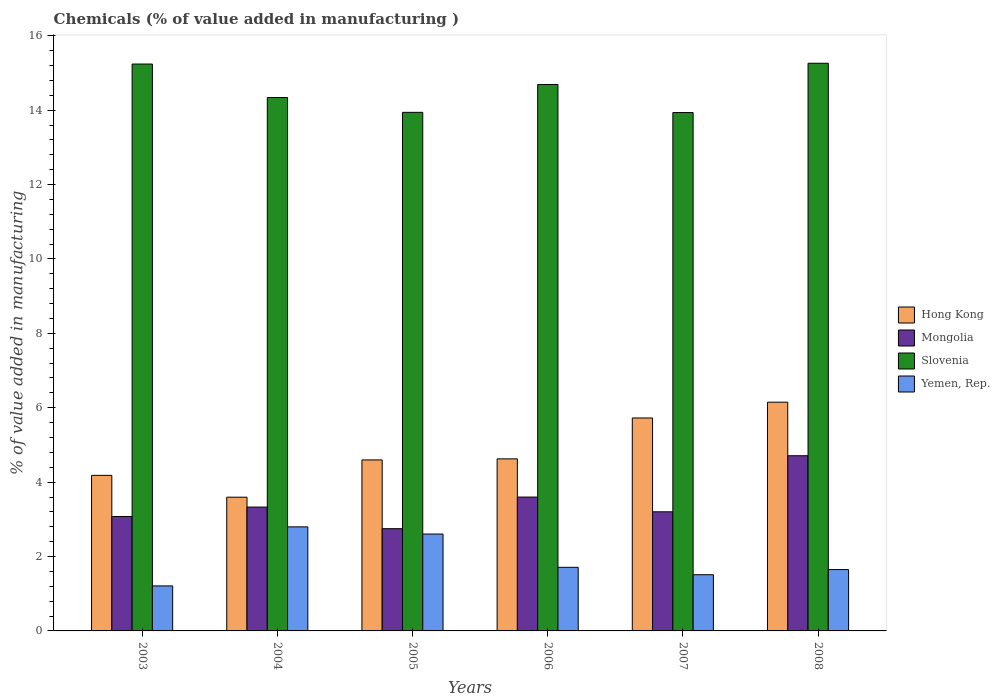Are the number of bars per tick equal to the number of legend labels?
Ensure brevity in your answer.  Yes. How many bars are there on the 6th tick from the left?
Make the answer very short. 4. What is the label of the 4th group of bars from the left?
Provide a succinct answer. 2006. What is the value added in manufacturing chemicals in Mongolia in 2007?
Make the answer very short. 3.2. Across all years, what is the maximum value added in manufacturing chemicals in Hong Kong?
Offer a terse response. 6.15. Across all years, what is the minimum value added in manufacturing chemicals in Hong Kong?
Keep it short and to the point. 3.59. In which year was the value added in manufacturing chemicals in Hong Kong maximum?
Your response must be concise. 2008. In which year was the value added in manufacturing chemicals in Hong Kong minimum?
Ensure brevity in your answer.  2004. What is the total value added in manufacturing chemicals in Hong Kong in the graph?
Give a very brief answer. 28.87. What is the difference between the value added in manufacturing chemicals in Mongolia in 2003 and that in 2005?
Offer a very short reply. 0.33. What is the difference between the value added in manufacturing chemicals in Hong Kong in 2007 and the value added in manufacturing chemicals in Mongolia in 2003?
Give a very brief answer. 2.65. What is the average value added in manufacturing chemicals in Yemen, Rep. per year?
Your answer should be compact. 1.91. In the year 2008, what is the difference between the value added in manufacturing chemicals in Slovenia and value added in manufacturing chemicals in Mongolia?
Your answer should be compact. 10.55. In how many years, is the value added in manufacturing chemicals in Yemen, Rep. greater than 15.2 %?
Offer a terse response. 0. What is the ratio of the value added in manufacturing chemicals in Slovenia in 2004 to that in 2008?
Make the answer very short. 0.94. Is the difference between the value added in manufacturing chemicals in Slovenia in 2003 and 2008 greater than the difference between the value added in manufacturing chemicals in Mongolia in 2003 and 2008?
Offer a very short reply. Yes. What is the difference between the highest and the second highest value added in manufacturing chemicals in Yemen, Rep.?
Your answer should be very brief. 0.19. What is the difference between the highest and the lowest value added in manufacturing chemicals in Mongolia?
Provide a short and direct response. 1.96. In how many years, is the value added in manufacturing chemicals in Slovenia greater than the average value added in manufacturing chemicals in Slovenia taken over all years?
Give a very brief answer. 3. Is it the case that in every year, the sum of the value added in manufacturing chemicals in Hong Kong and value added in manufacturing chemicals in Slovenia is greater than the sum of value added in manufacturing chemicals in Mongolia and value added in manufacturing chemicals in Yemen, Rep.?
Your answer should be compact. Yes. What does the 1st bar from the left in 2004 represents?
Give a very brief answer. Hong Kong. What does the 1st bar from the right in 2003 represents?
Provide a succinct answer. Yemen, Rep. Is it the case that in every year, the sum of the value added in manufacturing chemicals in Mongolia and value added in manufacturing chemicals in Hong Kong is greater than the value added in manufacturing chemicals in Yemen, Rep.?
Offer a very short reply. Yes. How many bars are there?
Make the answer very short. 24. How many years are there in the graph?
Offer a very short reply. 6. What is the title of the graph?
Ensure brevity in your answer.  Chemicals (% of value added in manufacturing ). Does "Sub-Saharan Africa (all income levels)" appear as one of the legend labels in the graph?
Keep it short and to the point. No. What is the label or title of the Y-axis?
Your answer should be compact. % of value added in manufacturing. What is the % of value added in manufacturing of Hong Kong in 2003?
Provide a succinct answer. 4.18. What is the % of value added in manufacturing of Mongolia in 2003?
Provide a short and direct response. 3.08. What is the % of value added in manufacturing in Slovenia in 2003?
Offer a terse response. 15.24. What is the % of value added in manufacturing of Yemen, Rep. in 2003?
Keep it short and to the point. 1.21. What is the % of value added in manufacturing in Hong Kong in 2004?
Give a very brief answer. 3.59. What is the % of value added in manufacturing of Mongolia in 2004?
Keep it short and to the point. 3.33. What is the % of value added in manufacturing in Slovenia in 2004?
Provide a short and direct response. 14.34. What is the % of value added in manufacturing in Yemen, Rep. in 2004?
Your answer should be compact. 2.8. What is the % of value added in manufacturing in Hong Kong in 2005?
Offer a very short reply. 4.6. What is the % of value added in manufacturing of Mongolia in 2005?
Provide a short and direct response. 2.75. What is the % of value added in manufacturing in Slovenia in 2005?
Keep it short and to the point. 13.94. What is the % of value added in manufacturing in Yemen, Rep. in 2005?
Your answer should be compact. 2.6. What is the % of value added in manufacturing in Hong Kong in 2006?
Your answer should be compact. 4.63. What is the % of value added in manufacturing in Mongolia in 2006?
Your answer should be compact. 3.6. What is the % of value added in manufacturing of Slovenia in 2006?
Keep it short and to the point. 14.69. What is the % of value added in manufacturing of Yemen, Rep. in 2006?
Keep it short and to the point. 1.71. What is the % of value added in manufacturing in Hong Kong in 2007?
Your answer should be compact. 5.72. What is the % of value added in manufacturing of Mongolia in 2007?
Ensure brevity in your answer.  3.2. What is the % of value added in manufacturing in Slovenia in 2007?
Ensure brevity in your answer.  13.93. What is the % of value added in manufacturing of Yemen, Rep. in 2007?
Your response must be concise. 1.51. What is the % of value added in manufacturing in Hong Kong in 2008?
Your answer should be compact. 6.15. What is the % of value added in manufacturing in Mongolia in 2008?
Offer a very short reply. 4.71. What is the % of value added in manufacturing in Slovenia in 2008?
Give a very brief answer. 15.26. What is the % of value added in manufacturing in Yemen, Rep. in 2008?
Ensure brevity in your answer.  1.65. Across all years, what is the maximum % of value added in manufacturing of Hong Kong?
Make the answer very short. 6.15. Across all years, what is the maximum % of value added in manufacturing in Mongolia?
Give a very brief answer. 4.71. Across all years, what is the maximum % of value added in manufacturing of Slovenia?
Offer a very short reply. 15.26. Across all years, what is the maximum % of value added in manufacturing in Yemen, Rep.?
Make the answer very short. 2.8. Across all years, what is the minimum % of value added in manufacturing of Hong Kong?
Provide a succinct answer. 3.59. Across all years, what is the minimum % of value added in manufacturing in Mongolia?
Your response must be concise. 2.75. Across all years, what is the minimum % of value added in manufacturing of Slovenia?
Your answer should be compact. 13.93. Across all years, what is the minimum % of value added in manufacturing of Yemen, Rep.?
Make the answer very short. 1.21. What is the total % of value added in manufacturing of Hong Kong in the graph?
Provide a short and direct response. 28.87. What is the total % of value added in manufacturing of Mongolia in the graph?
Keep it short and to the point. 20.66. What is the total % of value added in manufacturing of Slovenia in the graph?
Ensure brevity in your answer.  87.41. What is the total % of value added in manufacturing of Yemen, Rep. in the graph?
Keep it short and to the point. 11.48. What is the difference between the % of value added in manufacturing of Hong Kong in 2003 and that in 2004?
Make the answer very short. 0.59. What is the difference between the % of value added in manufacturing of Mongolia in 2003 and that in 2004?
Make the answer very short. -0.25. What is the difference between the % of value added in manufacturing of Slovenia in 2003 and that in 2004?
Make the answer very short. 0.9. What is the difference between the % of value added in manufacturing of Yemen, Rep. in 2003 and that in 2004?
Offer a terse response. -1.59. What is the difference between the % of value added in manufacturing of Hong Kong in 2003 and that in 2005?
Keep it short and to the point. -0.41. What is the difference between the % of value added in manufacturing of Mongolia in 2003 and that in 2005?
Make the answer very short. 0.33. What is the difference between the % of value added in manufacturing of Slovenia in 2003 and that in 2005?
Give a very brief answer. 1.3. What is the difference between the % of value added in manufacturing in Yemen, Rep. in 2003 and that in 2005?
Keep it short and to the point. -1.39. What is the difference between the % of value added in manufacturing of Hong Kong in 2003 and that in 2006?
Your answer should be compact. -0.44. What is the difference between the % of value added in manufacturing in Mongolia in 2003 and that in 2006?
Your response must be concise. -0.52. What is the difference between the % of value added in manufacturing in Slovenia in 2003 and that in 2006?
Your answer should be compact. 0.55. What is the difference between the % of value added in manufacturing in Yemen, Rep. in 2003 and that in 2006?
Provide a short and direct response. -0.5. What is the difference between the % of value added in manufacturing of Hong Kong in 2003 and that in 2007?
Give a very brief answer. -1.54. What is the difference between the % of value added in manufacturing of Mongolia in 2003 and that in 2007?
Your answer should be compact. -0.13. What is the difference between the % of value added in manufacturing of Slovenia in 2003 and that in 2007?
Provide a short and direct response. 1.3. What is the difference between the % of value added in manufacturing in Yemen, Rep. in 2003 and that in 2007?
Provide a short and direct response. -0.3. What is the difference between the % of value added in manufacturing of Hong Kong in 2003 and that in 2008?
Offer a terse response. -1.97. What is the difference between the % of value added in manufacturing of Mongolia in 2003 and that in 2008?
Give a very brief answer. -1.63. What is the difference between the % of value added in manufacturing of Slovenia in 2003 and that in 2008?
Offer a very short reply. -0.02. What is the difference between the % of value added in manufacturing of Yemen, Rep. in 2003 and that in 2008?
Your answer should be very brief. -0.44. What is the difference between the % of value added in manufacturing of Hong Kong in 2004 and that in 2005?
Give a very brief answer. -1. What is the difference between the % of value added in manufacturing in Mongolia in 2004 and that in 2005?
Offer a very short reply. 0.58. What is the difference between the % of value added in manufacturing of Slovenia in 2004 and that in 2005?
Keep it short and to the point. 0.4. What is the difference between the % of value added in manufacturing of Yemen, Rep. in 2004 and that in 2005?
Your answer should be compact. 0.19. What is the difference between the % of value added in manufacturing of Hong Kong in 2004 and that in 2006?
Ensure brevity in your answer.  -1.03. What is the difference between the % of value added in manufacturing of Mongolia in 2004 and that in 2006?
Make the answer very short. -0.27. What is the difference between the % of value added in manufacturing of Slovenia in 2004 and that in 2006?
Keep it short and to the point. -0.35. What is the difference between the % of value added in manufacturing in Yemen, Rep. in 2004 and that in 2006?
Offer a terse response. 1.09. What is the difference between the % of value added in manufacturing of Hong Kong in 2004 and that in 2007?
Ensure brevity in your answer.  -2.13. What is the difference between the % of value added in manufacturing in Mongolia in 2004 and that in 2007?
Your answer should be compact. 0.13. What is the difference between the % of value added in manufacturing of Slovenia in 2004 and that in 2007?
Your response must be concise. 0.4. What is the difference between the % of value added in manufacturing in Yemen, Rep. in 2004 and that in 2007?
Offer a terse response. 1.29. What is the difference between the % of value added in manufacturing of Hong Kong in 2004 and that in 2008?
Your answer should be very brief. -2.55. What is the difference between the % of value added in manufacturing of Mongolia in 2004 and that in 2008?
Offer a terse response. -1.38. What is the difference between the % of value added in manufacturing in Slovenia in 2004 and that in 2008?
Your answer should be compact. -0.92. What is the difference between the % of value added in manufacturing of Yemen, Rep. in 2004 and that in 2008?
Your response must be concise. 1.15. What is the difference between the % of value added in manufacturing in Hong Kong in 2005 and that in 2006?
Your response must be concise. -0.03. What is the difference between the % of value added in manufacturing in Mongolia in 2005 and that in 2006?
Provide a succinct answer. -0.85. What is the difference between the % of value added in manufacturing in Slovenia in 2005 and that in 2006?
Your answer should be very brief. -0.75. What is the difference between the % of value added in manufacturing in Yemen, Rep. in 2005 and that in 2006?
Give a very brief answer. 0.89. What is the difference between the % of value added in manufacturing in Hong Kong in 2005 and that in 2007?
Provide a short and direct response. -1.13. What is the difference between the % of value added in manufacturing in Mongolia in 2005 and that in 2007?
Provide a succinct answer. -0.45. What is the difference between the % of value added in manufacturing in Slovenia in 2005 and that in 2007?
Offer a very short reply. 0.01. What is the difference between the % of value added in manufacturing of Yemen, Rep. in 2005 and that in 2007?
Keep it short and to the point. 1.09. What is the difference between the % of value added in manufacturing of Hong Kong in 2005 and that in 2008?
Your answer should be compact. -1.55. What is the difference between the % of value added in manufacturing in Mongolia in 2005 and that in 2008?
Provide a succinct answer. -1.96. What is the difference between the % of value added in manufacturing of Slovenia in 2005 and that in 2008?
Keep it short and to the point. -1.32. What is the difference between the % of value added in manufacturing of Yemen, Rep. in 2005 and that in 2008?
Your answer should be very brief. 0.96. What is the difference between the % of value added in manufacturing of Hong Kong in 2006 and that in 2007?
Your response must be concise. -1.1. What is the difference between the % of value added in manufacturing of Mongolia in 2006 and that in 2007?
Your answer should be compact. 0.4. What is the difference between the % of value added in manufacturing in Slovenia in 2006 and that in 2007?
Make the answer very short. 0.76. What is the difference between the % of value added in manufacturing of Yemen, Rep. in 2006 and that in 2007?
Keep it short and to the point. 0.2. What is the difference between the % of value added in manufacturing in Hong Kong in 2006 and that in 2008?
Your answer should be compact. -1.52. What is the difference between the % of value added in manufacturing of Mongolia in 2006 and that in 2008?
Ensure brevity in your answer.  -1.11. What is the difference between the % of value added in manufacturing of Slovenia in 2006 and that in 2008?
Your answer should be very brief. -0.57. What is the difference between the % of value added in manufacturing in Yemen, Rep. in 2006 and that in 2008?
Provide a short and direct response. 0.06. What is the difference between the % of value added in manufacturing in Hong Kong in 2007 and that in 2008?
Your response must be concise. -0.42. What is the difference between the % of value added in manufacturing in Mongolia in 2007 and that in 2008?
Give a very brief answer. -1.51. What is the difference between the % of value added in manufacturing in Slovenia in 2007 and that in 2008?
Offer a terse response. -1.33. What is the difference between the % of value added in manufacturing of Yemen, Rep. in 2007 and that in 2008?
Ensure brevity in your answer.  -0.14. What is the difference between the % of value added in manufacturing in Hong Kong in 2003 and the % of value added in manufacturing in Mongolia in 2004?
Your answer should be compact. 0.85. What is the difference between the % of value added in manufacturing of Hong Kong in 2003 and the % of value added in manufacturing of Slovenia in 2004?
Provide a succinct answer. -10.16. What is the difference between the % of value added in manufacturing in Hong Kong in 2003 and the % of value added in manufacturing in Yemen, Rep. in 2004?
Your answer should be very brief. 1.39. What is the difference between the % of value added in manufacturing of Mongolia in 2003 and the % of value added in manufacturing of Slovenia in 2004?
Keep it short and to the point. -11.26. What is the difference between the % of value added in manufacturing in Mongolia in 2003 and the % of value added in manufacturing in Yemen, Rep. in 2004?
Make the answer very short. 0.28. What is the difference between the % of value added in manufacturing in Slovenia in 2003 and the % of value added in manufacturing in Yemen, Rep. in 2004?
Give a very brief answer. 12.44. What is the difference between the % of value added in manufacturing in Hong Kong in 2003 and the % of value added in manufacturing in Mongolia in 2005?
Your response must be concise. 1.43. What is the difference between the % of value added in manufacturing in Hong Kong in 2003 and the % of value added in manufacturing in Slovenia in 2005?
Keep it short and to the point. -9.76. What is the difference between the % of value added in manufacturing of Hong Kong in 2003 and the % of value added in manufacturing of Yemen, Rep. in 2005?
Offer a very short reply. 1.58. What is the difference between the % of value added in manufacturing of Mongolia in 2003 and the % of value added in manufacturing of Slovenia in 2005?
Provide a short and direct response. -10.86. What is the difference between the % of value added in manufacturing in Mongolia in 2003 and the % of value added in manufacturing in Yemen, Rep. in 2005?
Offer a very short reply. 0.47. What is the difference between the % of value added in manufacturing of Slovenia in 2003 and the % of value added in manufacturing of Yemen, Rep. in 2005?
Your answer should be very brief. 12.63. What is the difference between the % of value added in manufacturing of Hong Kong in 2003 and the % of value added in manufacturing of Mongolia in 2006?
Ensure brevity in your answer.  0.58. What is the difference between the % of value added in manufacturing of Hong Kong in 2003 and the % of value added in manufacturing of Slovenia in 2006?
Provide a short and direct response. -10.51. What is the difference between the % of value added in manufacturing in Hong Kong in 2003 and the % of value added in manufacturing in Yemen, Rep. in 2006?
Provide a short and direct response. 2.47. What is the difference between the % of value added in manufacturing in Mongolia in 2003 and the % of value added in manufacturing in Slovenia in 2006?
Offer a terse response. -11.61. What is the difference between the % of value added in manufacturing of Mongolia in 2003 and the % of value added in manufacturing of Yemen, Rep. in 2006?
Make the answer very short. 1.37. What is the difference between the % of value added in manufacturing of Slovenia in 2003 and the % of value added in manufacturing of Yemen, Rep. in 2006?
Provide a short and direct response. 13.53. What is the difference between the % of value added in manufacturing in Hong Kong in 2003 and the % of value added in manufacturing in Mongolia in 2007?
Keep it short and to the point. 0.98. What is the difference between the % of value added in manufacturing of Hong Kong in 2003 and the % of value added in manufacturing of Slovenia in 2007?
Ensure brevity in your answer.  -9.75. What is the difference between the % of value added in manufacturing in Hong Kong in 2003 and the % of value added in manufacturing in Yemen, Rep. in 2007?
Provide a short and direct response. 2.67. What is the difference between the % of value added in manufacturing of Mongolia in 2003 and the % of value added in manufacturing of Slovenia in 2007?
Offer a terse response. -10.86. What is the difference between the % of value added in manufacturing of Mongolia in 2003 and the % of value added in manufacturing of Yemen, Rep. in 2007?
Your answer should be very brief. 1.57. What is the difference between the % of value added in manufacturing of Slovenia in 2003 and the % of value added in manufacturing of Yemen, Rep. in 2007?
Your answer should be very brief. 13.73. What is the difference between the % of value added in manufacturing in Hong Kong in 2003 and the % of value added in manufacturing in Mongolia in 2008?
Ensure brevity in your answer.  -0.53. What is the difference between the % of value added in manufacturing in Hong Kong in 2003 and the % of value added in manufacturing in Slovenia in 2008?
Your answer should be compact. -11.08. What is the difference between the % of value added in manufacturing in Hong Kong in 2003 and the % of value added in manufacturing in Yemen, Rep. in 2008?
Provide a succinct answer. 2.53. What is the difference between the % of value added in manufacturing in Mongolia in 2003 and the % of value added in manufacturing in Slovenia in 2008?
Offer a very short reply. -12.18. What is the difference between the % of value added in manufacturing of Mongolia in 2003 and the % of value added in manufacturing of Yemen, Rep. in 2008?
Your answer should be very brief. 1.43. What is the difference between the % of value added in manufacturing of Slovenia in 2003 and the % of value added in manufacturing of Yemen, Rep. in 2008?
Offer a terse response. 13.59. What is the difference between the % of value added in manufacturing of Hong Kong in 2004 and the % of value added in manufacturing of Mongolia in 2005?
Provide a short and direct response. 0.85. What is the difference between the % of value added in manufacturing of Hong Kong in 2004 and the % of value added in manufacturing of Slovenia in 2005?
Your answer should be very brief. -10.35. What is the difference between the % of value added in manufacturing of Mongolia in 2004 and the % of value added in manufacturing of Slovenia in 2005?
Make the answer very short. -10.61. What is the difference between the % of value added in manufacturing in Mongolia in 2004 and the % of value added in manufacturing in Yemen, Rep. in 2005?
Give a very brief answer. 0.72. What is the difference between the % of value added in manufacturing of Slovenia in 2004 and the % of value added in manufacturing of Yemen, Rep. in 2005?
Keep it short and to the point. 11.74. What is the difference between the % of value added in manufacturing in Hong Kong in 2004 and the % of value added in manufacturing in Mongolia in 2006?
Give a very brief answer. -0. What is the difference between the % of value added in manufacturing in Hong Kong in 2004 and the % of value added in manufacturing in Slovenia in 2006?
Provide a succinct answer. -11.1. What is the difference between the % of value added in manufacturing of Hong Kong in 2004 and the % of value added in manufacturing of Yemen, Rep. in 2006?
Your answer should be very brief. 1.89. What is the difference between the % of value added in manufacturing of Mongolia in 2004 and the % of value added in manufacturing of Slovenia in 2006?
Your response must be concise. -11.36. What is the difference between the % of value added in manufacturing of Mongolia in 2004 and the % of value added in manufacturing of Yemen, Rep. in 2006?
Your answer should be very brief. 1.62. What is the difference between the % of value added in manufacturing in Slovenia in 2004 and the % of value added in manufacturing in Yemen, Rep. in 2006?
Provide a succinct answer. 12.63. What is the difference between the % of value added in manufacturing of Hong Kong in 2004 and the % of value added in manufacturing of Mongolia in 2007?
Your answer should be compact. 0.39. What is the difference between the % of value added in manufacturing in Hong Kong in 2004 and the % of value added in manufacturing in Slovenia in 2007?
Your answer should be very brief. -10.34. What is the difference between the % of value added in manufacturing in Hong Kong in 2004 and the % of value added in manufacturing in Yemen, Rep. in 2007?
Offer a terse response. 2.08. What is the difference between the % of value added in manufacturing in Mongolia in 2004 and the % of value added in manufacturing in Slovenia in 2007?
Offer a terse response. -10.61. What is the difference between the % of value added in manufacturing of Mongolia in 2004 and the % of value added in manufacturing of Yemen, Rep. in 2007?
Keep it short and to the point. 1.82. What is the difference between the % of value added in manufacturing of Slovenia in 2004 and the % of value added in manufacturing of Yemen, Rep. in 2007?
Provide a succinct answer. 12.83. What is the difference between the % of value added in manufacturing in Hong Kong in 2004 and the % of value added in manufacturing in Mongolia in 2008?
Your answer should be very brief. -1.11. What is the difference between the % of value added in manufacturing in Hong Kong in 2004 and the % of value added in manufacturing in Slovenia in 2008?
Offer a terse response. -11.67. What is the difference between the % of value added in manufacturing of Hong Kong in 2004 and the % of value added in manufacturing of Yemen, Rep. in 2008?
Give a very brief answer. 1.95. What is the difference between the % of value added in manufacturing in Mongolia in 2004 and the % of value added in manufacturing in Slovenia in 2008?
Provide a short and direct response. -11.93. What is the difference between the % of value added in manufacturing in Mongolia in 2004 and the % of value added in manufacturing in Yemen, Rep. in 2008?
Ensure brevity in your answer.  1.68. What is the difference between the % of value added in manufacturing of Slovenia in 2004 and the % of value added in manufacturing of Yemen, Rep. in 2008?
Ensure brevity in your answer.  12.69. What is the difference between the % of value added in manufacturing in Hong Kong in 2005 and the % of value added in manufacturing in Mongolia in 2006?
Offer a very short reply. 1. What is the difference between the % of value added in manufacturing of Hong Kong in 2005 and the % of value added in manufacturing of Slovenia in 2006?
Your response must be concise. -10.09. What is the difference between the % of value added in manufacturing of Hong Kong in 2005 and the % of value added in manufacturing of Yemen, Rep. in 2006?
Your answer should be compact. 2.89. What is the difference between the % of value added in manufacturing in Mongolia in 2005 and the % of value added in manufacturing in Slovenia in 2006?
Give a very brief answer. -11.94. What is the difference between the % of value added in manufacturing in Mongolia in 2005 and the % of value added in manufacturing in Yemen, Rep. in 2006?
Your answer should be very brief. 1.04. What is the difference between the % of value added in manufacturing of Slovenia in 2005 and the % of value added in manufacturing of Yemen, Rep. in 2006?
Your response must be concise. 12.23. What is the difference between the % of value added in manufacturing of Hong Kong in 2005 and the % of value added in manufacturing of Mongolia in 2007?
Your answer should be compact. 1.39. What is the difference between the % of value added in manufacturing in Hong Kong in 2005 and the % of value added in manufacturing in Slovenia in 2007?
Provide a succinct answer. -9.34. What is the difference between the % of value added in manufacturing of Hong Kong in 2005 and the % of value added in manufacturing of Yemen, Rep. in 2007?
Your answer should be very brief. 3.09. What is the difference between the % of value added in manufacturing in Mongolia in 2005 and the % of value added in manufacturing in Slovenia in 2007?
Keep it short and to the point. -11.19. What is the difference between the % of value added in manufacturing of Mongolia in 2005 and the % of value added in manufacturing of Yemen, Rep. in 2007?
Give a very brief answer. 1.24. What is the difference between the % of value added in manufacturing of Slovenia in 2005 and the % of value added in manufacturing of Yemen, Rep. in 2007?
Your answer should be compact. 12.43. What is the difference between the % of value added in manufacturing in Hong Kong in 2005 and the % of value added in manufacturing in Mongolia in 2008?
Keep it short and to the point. -0.11. What is the difference between the % of value added in manufacturing of Hong Kong in 2005 and the % of value added in manufacturing of Slovenia in 2008?
Keep it short and to the point. -10.66. What is the difference between the % of value added in manufacturing in Hong Kong in 2005 and the % of value added in manufacturing in Yemen, Rep. in 2008?
Give a very brief answer. 2.95. What is the difference between the % of value added in manufacturing in Mongolia in 2005 and the % of value added in manufacturing in Slovenia in 2008?
Provide a succinct answer. -12.51. What is the difference between the % of value added in manufacturing of Mongolia in 2005 and the % of value added in manufacturing of Yemen, Rep. in 2008?
Offer a terse response. 1.1. What is the difference between the % of value added in manufacturing in Slovenia in 2005 and the % of value added in manufacturing in Yemen, Rep. in 2008?
Keep it short and to the point. 12.29. What is the difference between the % of value added in manufacturing in Hong Kong in 2006 and the % of value added in manufacturing in Mongolia in 2007?
Offer a very short reply. 1.42. What is the difference between the % of value added in manufacturing in Hong Kong in 2006 and the % of value added in manufacturing in Slovenia in 2007?
Your answer should be very brief. -9.31. What is the difference between the % of value added in manufacturing in Hong Kong in 2006 and the % of value added in manufacturing in Yemen, Rep. in 2007?
Ensure brevity in your answer.  3.11. What is the difference between the % of value added in manufacturing in Mongolia in 2006 and the % of value added in manufacturing in Slovenia in 2007?
Ensure brevity in your answer.  -10.34. What is the difference between the % of value added in manufacturing of Mongolia in 2006 and the % of value added in manufacturing of Yemen, Rep. in 2007?
Provide a succinct answer. 2.09. What is the difference between the % of value added in manufacturing in Slovenia in 2006 and the % of value added in manufacturing in Yemen, Rep. in 2007?
Your answer should be very brief. 13.18. What is the difference between the % of value added in manufacturing in Hong Kong in 2006 and the % of value added in manufacturing in Mongolia in 2008?
Your response must be concise. -0.08. What is the difference between the % of value added in manufacturing of Hong Kong in 2006 and the % of value added in manufacturing of Slovenia in 2008?
Give a very brief answer. -10.63. What is the difference between the % of value added in manufacturing of Hong Kong in 2006 and the % of value added in manufacturing of Yemen, Rep. in 2008?
Ensure brevity in your answer.  2.98. What is the difference between the % of value added in manufacturing of Mongolia in 2006 and the % of value added in manufacturing of Slovenia in 2008?
Offer a terse response. -11.66. What is the difference between the % of value added in manufacturing of Mongolia in 2006 and the % of value added in manufacturing of Yemen, Rep. in 2008?
Make the answer very short. 1.95. What is the difference between the % of value added in manufacturing of Slovenia in 2006 and the % of value added in manufacturing of Yemen, Rep. in 2008?
Provide a succinct answer. 13.04. What is the difference between the % of value added in manufacturing in Hong Kong in 2007 and the % of value added in manufacturing in Mongolia in 2008?
Your answer should be compact. 1.02. What is the difference between the % of value added in manufacturing in Hong Kong in 2007 and the % of value added in manufacturing in Slovenia in 2008?
Offer a terse response. -9.54. What is the difference between the % of value added in manufacturing in Hong Kong in 2007 and the % of value added in manufacturing in Yemen, Rep. in 2008?
Your response must be concise. 4.08. What is the difference between the % of value added in manufacturing of Mongolia in 2007 and the % of value added in manufacturing of Slovenia in 2008?
Provide a succinct answer. -12.06. What is the difference between the % of value added in manufacturing in Mongolia in 2007 and the % of value added in manufacturing in Yemen, Rep. in 2008?
Offer a terse response. 1.55. What is the difference between the % of value added in manufacturing in Slovenia in 2007 and the % of value added in manufacturing in Yemen, Rep. in 2008?
Your answer should be compact. 12.29. What is the average % of value added in manufacturing in Hong Kong per year?
Keep it short and to the point. 4.81. What is the average % of value added in manufacturing in Mongolia per year?
Provide a succinct answer. 3.44. What is the average % of value added in manufacturing of Slovenia per year?
Give a very brief answer. 14.57. What is the average % of value added in manufacturing of Yemen, Rep. per year?
Ensure brevity in your answer.  1.91. In the year 2003, what is the difference between the % of value added in manufacturing of Hong Kong and % of value added in manufacturing of Mongolia?
Offer a very short reply. 1.11. In the year 2003, what is the difference between the % of value added in manufacturing in Hong Kong and % of value added in manufacturing in Slovenia?
Your response must be concise. -11.06. In the year 2003, what is the difference between the % of value added in manufacturing in Hong Kong and % of value added in manufacturing in Yemen, Rep.?
Your answer should be compact. 2.97. In the year 2003, what is the difference between the % of value added in manufacturing in Mongolia and % of value added in manufacturing in Slovenia?
Your answer should be compact. -12.16. In the year 2003, what is the difference between the % of value added in manufacturing in Mongolia and % of value added in manufacturing in Yemen, Rep.?
Offer a terse response. 1.87. In the year 2003, what is the difference between the % of value added in manufacturing of Slovenia and % of value added in manufacturing of Yemen, Rep.?
Offer a terse response. 14.03. In the year 2004, what is the difference between the % of value added in manufacturing in Hong Kong and % of value added in manufacturing in Mongolia?
Provide a short and direct response. 0.27. In the year 2004, what is the difference between the % of value added in manufacturing of Hong Kong and % of value added in manufacturing of Slovenia?
Offer a terse response. -10.74. In the year 2004, what is the difference between the % of value added in manufacturing of Hong Kong and % of value added in manufacturing of Yemen, Rep.?
Your answer should be very brief. 0.8. In the year 2004, what is the difference between the % of value added in manufacturing of Mongolia and % of value added in manufacturing of Slovenia?
Offer a very short reply. -11.01. In the year 2004, what is the difference between the % of value added in manufacturing of Mongolia and % of value added in manufacturing of Yemen, Rep.?
Provide a short and direct response. 0.53. In the year 2004, what is the difference between the % of value added in manufacturing in Slovenia and % of value added in manufacturing in Yemen, Rep.?
Your response must be concise. 11.54. In the year 2005, what is the difference between the % of value added in manufacturing in Hong Kong and % of value added in manufacturing in Mongolia?
Your answer should be very brief. 1.85. In the year 2005, what is the difference between the % of value added in manufacturing of Hong Kong and % of value added in manufacturing of Slovenia?
Offer a terse response. -9.34. In the year 2005, what is the difference between the % of value added in manufacturing of Hong Kong and % of value added in manufacturing of Yemen, Rep.?
Your answer should be very brief. 1.99. In the year 2005, what is the difference between the % of value added in manufacturing in Mongolia and % of value added in manufacturing in Slovenia?
Offer a terse response. -11.19. In the year 2005, what is the difference between the % of value added in manufacturing in Mongolia and % of value added in manufacturing in Yemen, Rep.?
Keep it short and to the point. 0.14. In the year 2005, what is the difference between the % of value added in manufacturing in Slovenia and % of value added in manufacturing in Yemen, Rep.?
Offer a terse response. 11.34. In the year 2006, what is the difference between the % of value added in manufacturing of Hong Kong and % of value added in manufacturing of Mongolia?
Ensure brevity in your answer.  1.03. In the year 2006, what is the difference between the % of value added in manufacturing of Hong Kong and % of value added in manufacturing of Slovenia?
Provide a short and direct response. -10.06. In the year 2006, what is the difference between the % of value added in manufacturing of Hong Kong and % of value added in manufacturing of Yemen, Rep.?
Your answer should be compact. 2.92. In the year 2006, what is the difference between the % of value added in manufacturing in Mongolia and % of value added in manufacturing in Slovenia?
Your answer should be compact. -11.09. In the year 2006, what is the difference between the % of value added in manufacturing in Mongolia and % of value added in manufacturing in Yemen, Rep.?
Your response must be concise. 1.89. In the year 2006, what is the difference between the % of value added in manufacturing of Slovenia and % of value added in manufacturing of Yemen, Rep.?
Provide a short and direct response. 12.98. In the year 2007, what is the difference between the % of value added in manufacturing in Hong Kong and % of value added in manufacturing in Mongolia?
Offer a terse response. 2.52. In the year 2007, what is the difference between the % of value added in manufacturing in Hong Kong and % of value added in manufacturing in Slovenia?
Your answer should be very brief. -8.21. In the year 2007, what is the difference between the % of value added in manufacturing in Hong Kong and % of value added in manufacturing in Yemen, Rep.?
Your answer should be compact. 4.21. In the year 2007, what is the difference between the % of value added in manufacturing of Mongolia and % of value added in manufacturing of Slovenia?
Your answer should be very brief. -10.73. In the year 2007, what is the difference between the % of value added in manufacturing in Mongolia and % of value added in manufacturing in Yemen, Rep.?
Your response must be concise. 1.69. In the year 2007, what is the difference between the % of value added in manufacturing of Slovenia and % of value added in manufacturing of Yemen, Rep.?
Offer a very short reply. 12.42. In the year 2008, what is the difference between the % of value added in manufacturing in Hong Kong and % of value added in manufacturing in Mongolia?
Your answer should be very brief. 1.44. In the year 2008, what is the difference between the % of value added in manufacturing of Hong Kong and % of value added in manufacturing of Slovenia?
Your response must be concise. -9.11. In the year 2008, what is the difference between the % of value added in manufacturing of Hong Kong and % of value added in manufacturing of Yemen, Rep.?
Ensure brevity in your answer.  4.5. In the year 2008, what is the difference between the % of value added in manufacturing in Mongolia and % of value added in manufacturing in Slovenia?
Provide a succinct answer. -10.55. In the year 2008, what is the difference between the % of value added in manufacturing of Mongolia and % of value added in manufacturing of Yemen, Rep.?
Ensure brevity in your answer.  3.06. In the year 2008, what is the difference between the % of value added in manufacturing of Slovenia and % of value added in manufacturing of Yemen, Rep.?
Make the answer very short. 13.61. What is the ratio of the % of value added in manufacturing of Hong Kong in 2003 to that in 2004?
Give a very brief answer. 1.16. What is the ratio of the % of value added in manufacturing in Mongolia in 2003 to that in 2004?
Your answer should be compact. 0.92. What is the ratio of the % of value added in manufacturing of Slovenia in 2003 to that in 2004?
Your answer should be very brief. 1.06. What is the ratio of the % of value added in manufacturing of Yemen, Rep. in 2003 to that in 2004?
Give a very brief answer. 0.43. What is the ratio of the % of value added in manufacturing in Hong Kong in 2003 to that in 2005?
Keep it short and to the point. 0.91. What is the ratio of the % of value added in manufacturing of Mongolia in 2003 to that in 2005?
Your answer should be very brief. 1.12. What is the ratio of the % of value added in manufacturing of Slovenia in 2003 to that in 2005?
Offer a very short reply. 1.09. What is the ratio of the % of value added in manufacturing in Yemen, Rep. in 2003 to that in 2005?
Make the answer very short. 0.46. What is the ratio of the % of value added in manufacturing of Hong Kong in 2003 to that in 2006?
Provide a succinct answer. 0.9. What is the ratio of the % of value added in manufacturing of Mongolia in 2003 to that in 2006?
Provide a succinct answer. 0.85. What is the ratio of the % of value added in manufacturing of Slovenia in 2003 to that in 2006?
Make the answer very short. 1.04. What is the ratio of the % of value added in manufacturing in Yemen, Rep. in 2003 to that in 2006?
Provide a succinct answer. 0.71. What is the ratio of the % of value added in manufacturing of Hong Kong in 2003 to that in 2007?
Ensure brevity in your answer.  0.73. What is the ratio of the % of value added in manufacturing in Mongolia in 2003 to that in 2007?
Your answer should be very brief. 0.96. What is the ratio of the % of value added in manufacturing in Slovenia in 2003 to that in 2007?
Offer a very short reply. 1.09. What is the ratio of the % of value added in manufacturing in Yemen, Rep. in 2003 to that in 2007?
Provide a short and direct response. 0.8. What is the ratio of the % of value added in manufacturing in Hong Kong in 2003 to that in 2008?
Make the answer very short. 0.68. What is the ratio of the % of value added in manufacturing of Mongolia in 2003 to that in 2008?
Make the answer very short. 0.65. What is the ratio of the % of value added in manufacturing in Yemen, Rep. in 2003 to that in 2008?
Your answer should be compact. 0.73. What is the ratio of the % of value added in manufacturing of Hong Kong in 2004 to that in 2005?
Keep it short and to the point. 0.78. What is the ratio of the % of value added in manufacturing in Mongolia in 2004 to that in 2005?
Your response must be concise. 1.21. What is the ratio of the % of value added in manufacturing in Slovenia in 2004 to that in 2005?
Make the answer very short. 1.03. What is the ratio of the % of value added in manufacturing of Yemen, Rep. in 2004 to that in 2005?
Your answer should be very brief. 1.07. What is the ratio of the % of value added in manufacturing of Hong Kong in 2004 to that in 2006?
Offer a very short reply. 0.78. What is the ratio of the % of value added in manufacturing in Mongolia in 2004 to that in 2006?
Make the answer very short. 0.93. What is the ratio of the % of value added in manufacturing of Slovenia in 2004 to that in 2006?
Offer a very short reply. 0.98. What is the ratio of the % of value added in manufacturing of Yemen, Rep. in 2004 to that in 2006?
Give a very brief answer. 1.64. What is the ratio of the % of value added in manufacturing in Hong Kong in 2004 to that in 2007?
Your response must be concise. 0.63. What is the ratio of the % of value added in manufacturing of Mongolia in 2004 to that in 2007?
Give a very brief answer. 1.04. What is the ratio of the % of value added in manufacturing of Slovenia in 2004 to that in 2007?
Ensure brevity in your answer.  1.03. What is the ratio of the % of value added in manufacturing of Yemen, Rep. in 2004 to that in 2007?
Provide a short and direct response. 1.85. What is the ratio of the % of value added in manufacturing of Hong Kong in 2004 to that in 2008?
Make the answer very short. 0.58. What is the ratio of the % of value added in manufacturing in Mongolia in 2004 to that in 2008?
Your answer should be compact. 0.71. What is the ratio of the % of value added in manufacturing in Slovenia in 2004 to that in 2008?
Your answer should be compact. 0.94. What is the ratio of the % of value added in manufacturing in Yemen, Rep. in 2004 to that in 2008?
Offer a very short reply. 1.7. What is the ratio of the % of value added in manufacturing of Hong Kong in 2005 to that in 2006?
Ensure brevity in your answer.  0.99. What is the ratio of the % of value added in manufacturing of Mongolia in 2005 to that in 2006?
Give a very brief answer. 0.76. What is the ratio of the % of value added in manufacturing in Slovenia in 2005 to that in 2006?
Offer a terse response. 0.95. What is the ratio of the % of value added in manufacturing of Yemen, Rep. in 2005 to that in 2006?
Offer a very short reply. 1.52. What is the ratio of the % of value added in manufacturing of Hong Kong in 2005 to that in 2007?
Ensure brevity in your answer.  0.8. What is the ratio of the % of value added in manufacturing in Mongolia in 2005 to that in 2007?
Your response must be concise. 0.86. What is the ratio of the % of value added in manufacturing in Yemen, Rep. in 2005 to that in 2007?
Your response must be concise. 1.72. What is the ratio of the % of value added in manufacturing of Hong Kong in 2005 to that in 2008?
Give a very brief answer. 0.75. What is the ratio of the % of value added in manufacturing in Mongolia in 2005 to that in 2008?
Your answer should be compact. 0.58. What is the ratio of the % of value added in manufacturing in Slovenia in 2005 to that in 2008?
Provide a succinct answer. 0.91. What is the ratio of the % of value added in manufacturing in Yemen, Rep. in 2005 to that in 2008?
Give a very brief answer. 1.58. What is the ratio of the % of value added in manufacturing of Hong Kong in 2006 to that in 2007?
Give a very brief answer. 0.81. What is the ratio of the % of value added in manufacturing of Mongolia in 2006 to that in 2007?
Your answer should be very brief. 1.12. What is the ratio of the % of value added in manufacturing of Slovenia in 2006 to that in 2007?
Provide a succinct answer. 1.05. What is the ratio of the % of value added in manufacturing of Yemen, Rep. in 2006 to that in 2007?
Make the answer very short. 1.13. What is the ratio of the % of value added in manufacturing of Hong Kong in 2006 to that in 2008?
Ensure brevity in your answer.  0.75. What is the ratio of the % of value added in manufacturing of Mongolia in 2006 to that in 2008?
Give a very brief answer. 0.76. What is the ratio of the % of value added in manufacturing of Slovenia in 2006 to that in 2008?
Your answer should be very brief. 0.96. What is the ratio of the % of value added in manufacturing of Yemen, Rep. in 2006 to that in 2008?
Provide a succinct answer. 1.04. What is the ratio of the % of value added in manufacturing in Hong Kong in 2007 to that in 2008?
Your answer should be very brief. 0.93. What is the ratio of the % of value added in manufacturing of Mongolia in 2007 to that in 2008?
Keep it short and to the point. 0.68. What is the ratio of the % of value added in manufacturing in Slovenia in 2007 to that in 2008?
Keep it short and to the point. 0.91. What is the ratio of the % of value added in manufacturing in Yemen, Rep. in 2007 to that in 2008?
Provide a succinct answer. 0.92. What is the difference between the highest and the second highest % of value added in manufacturing in Hong Kong?
Keep it short and to the point. 0.42. What is the difference between the highest and the second highest % of value added in manufacturing of Mongolia?
Your response must be concise. 1.11. What is the difference between the highest and the second highest % of value added in manufacturing in Slovenia?
Make the answer very short. 0.02. What is the difference between the highest and the second highest % of value added in manufacturing of Yemen, Rep.?
Offer a terse response. 0.19. What is the difference between the highest and the lowest % of value added in manufacturing of Hong Kong?
Offer a terse response. 2.55. What is the difference between the highest and the lowest % of value added in manufacturing in Mongolia?
Your response must be concise. 1.96. What is the difference between the highest and the lowest % of value added in manufacturing in Slovenia?
Ensure brevity in your answer.  1.33. What is the difference between the highest and the lowest % of value added in manufacturing of Yemen, Rep.?
Your answer should be very brief. 1.59. 